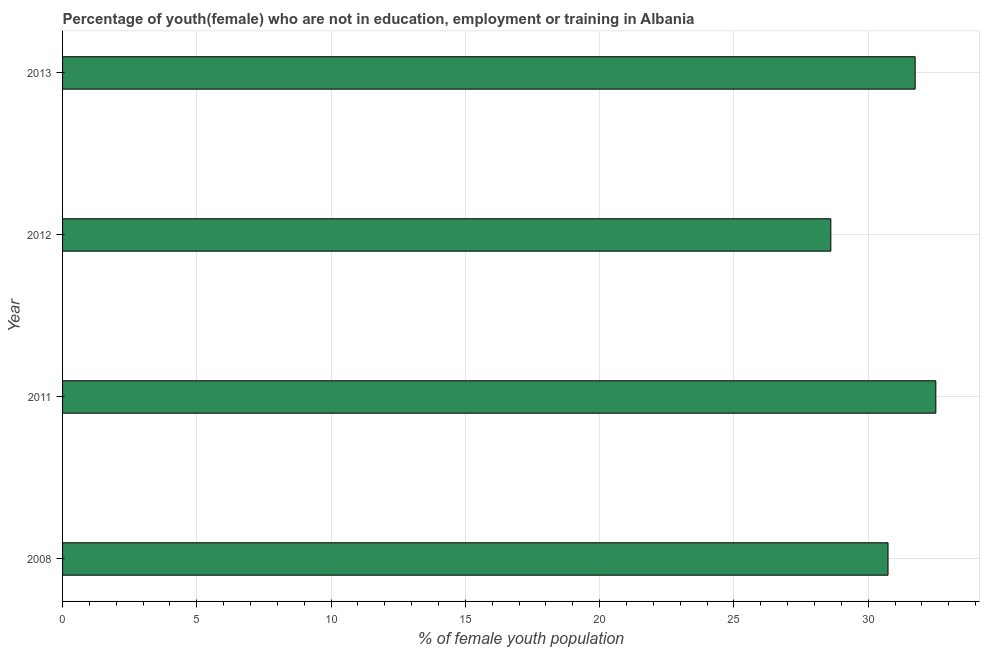Does the graph contain any zero values?
Offer a very short reply. No. What is the title of the graph?
Provide a short and direct response. Percentage of youth(female) who are not in education, employment or training in Albania. What is the label or title of the X-axis?
Make the answer very short. % of female youth population. What is the label or title of the Y-axis?
Your response must be concise. Year. What is the unemployed female youth population in 2013?
Your answer should be very brief. 31.75. Across all years, what is the maximum unemployed female youth population?
Your response must be concise. 32.52. Across all years, what is the minimum unemployed female youth population?
Your response must be concise. 28.61. What is the sum of the unemployed female youth population?
Ensure brevity in your answer.  123.62. What is the difference between the unemployed female youth population in 2011 and 2013?
Give a very brief answer. 0.77. What is the average unemployed female youth population per year?
Ensure brevity in your answer.  30.91. What is the median unemployed female youth population?
Ensure brevity in your answer.  31.24. In how many years, is the unemployed female youth population greater than 12 %?
Offer a terse response. 4. Do a majority of the years between 2013 and 2012 (inclusive) have unemployed female youth population greater than 14 %?
Your answer should be very brief. No. What is the ratio of the unemployed female youth population in 2011 to that in 2013?
Make the answer very short. 1.02. What is the difference between the highest and the second highest unemployed female youth population?
Provide a succinct answer. 0.77. What is the difference between the highest and the lowest unemployed female youth population?
Ensure brevity in your answer.  3.91. How many bars are there?
Offer a very short reply. 4. How many years are there in the graph?
Your answer should be very brief. 4. What is the difference between two consecutive major ticks on the X-axis?
Offer a terse response. 5. Are the values on the major ticks of X-axis written in scientific E-notation?
Your answer should be compact. No. What is the % of female youth population of 2008?
Ensure brevity in your answer.  30.74. What is the % of female youth population of 2011?
Provide a succinct answer. 32.52. What is the % of female youth population of 2012?
Keep it short and to the point. 28.61. What is the % of female youth population of 2013?
Provide a short and direct response. 31.75. What is the difference between the % of female youth population in 2008 and 2011?
Ensure brevity in your answer.  -1.78. What is the difference between the % of female youth population in 2008 and 2012?
Offer a very short reply. 2.13. What is the difference between the % of female youth population in 2008 and 2013?
Provide a short and direct response. -1.01. What is the difference between the % of female youth population in 2011 and 2012?
Offer a very short reply. 3.91. What is the difference between the % of female youth population in 2011 and 2013?
Give a very brief answer. 0.77. What is the difference between the % of female youth population in 2012 and 2013?
Provide a short and direct response. -3.14. What is the ratio of the % of female youth population in 2008 to that in 2011?
Your response must be concise. 0.94. What is the ratio of the % of female youth population in 2008 to that in 2012?
Your answer should be compact. 1.07. What is the ratio of the % of female youth population in 2011 to that in 2012?
Provide a succinct answer. 1.14. What is the ratio of the % of female youth population in 2012 to that in 2013?
Provide a succinct answer. 0.9. 